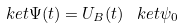Convert formula to latex. <formula><loc_0><loc_0><loc_500><loc_500>\ k e t { \Psi ( t ) } = U _ { B } ( t ) \, \ k e t { \psi _ { 0 } }</formula> 